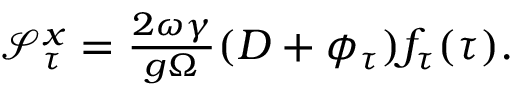Convert formula to latex. <formula><loc_0><loc_0><loc_500><loc_500>\begin{array} { r } { \mathcal { S } _ { \tau } ^ { x } = \frac { 2 \omega \gamma } { g \Omega } ( D + \phi _ { \tau } ) f _ { \tau } ( \tau ) . } \end{array}</formula> 